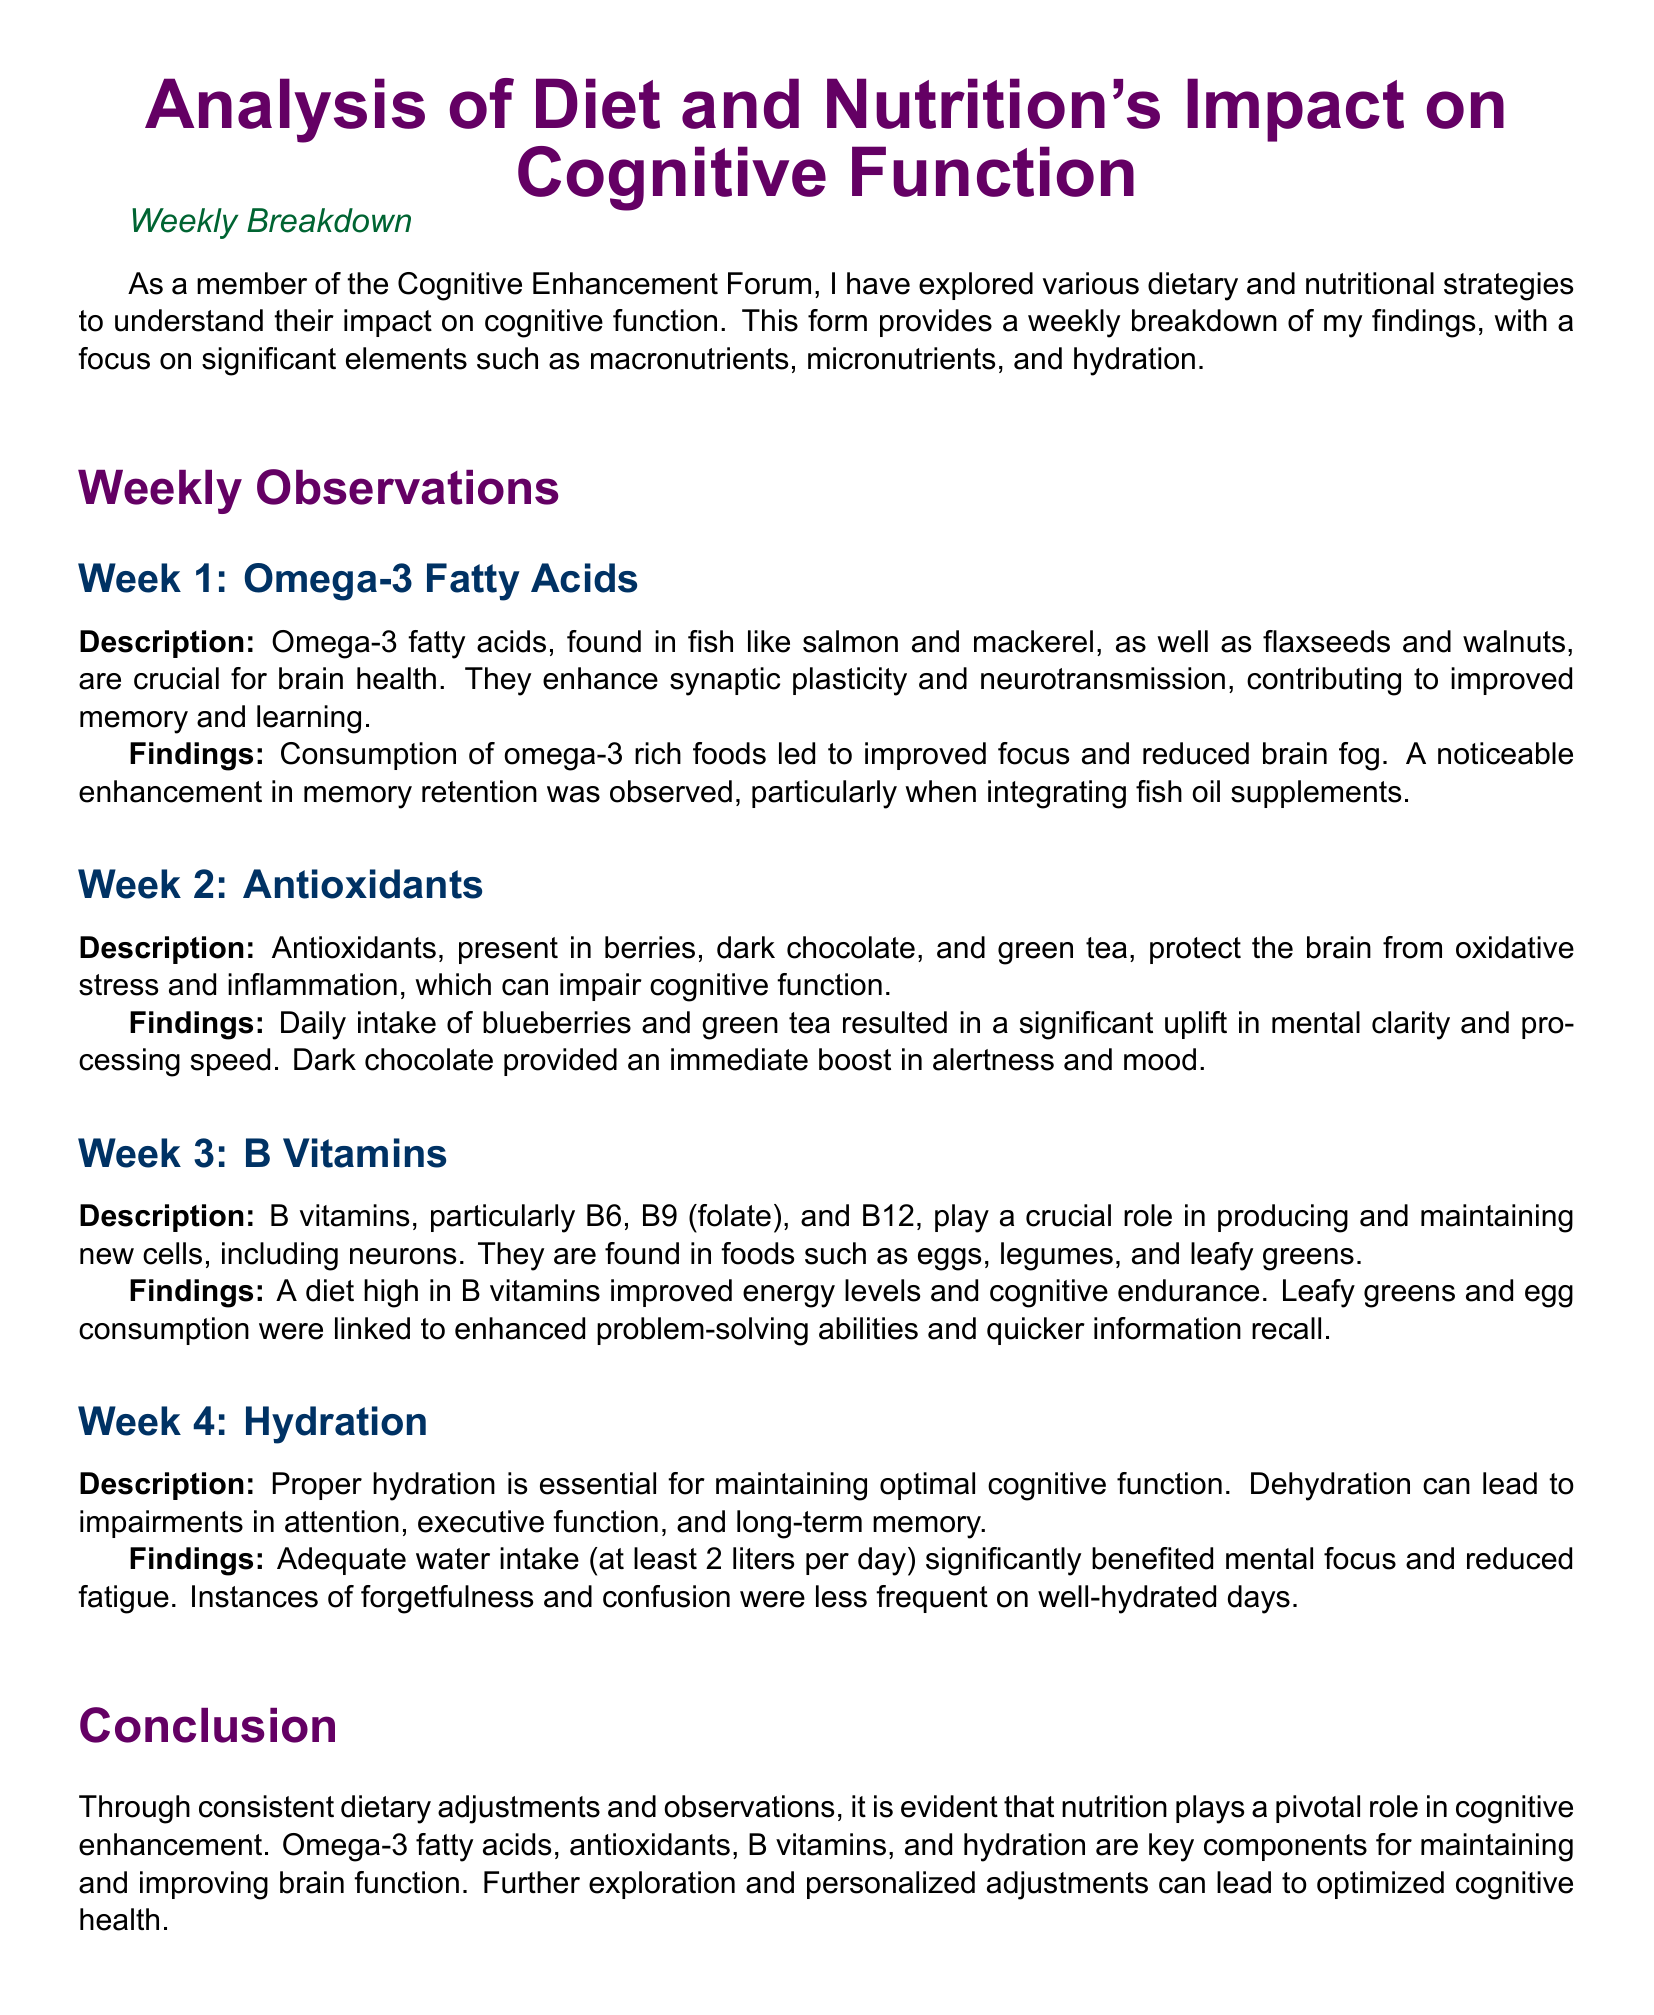What are the key components for maintaining and improving brain function? The key components mentioned in the document for maintaining and improving brain function are omega-3 fatty acids, antioxidants, B vitamins, and hydration.
Answer: omega-3 fatty acids, antioxidants, B vitamins, and hydration Which week focused on hydration? The document has a section for each week, and hydration is discussed in Week 4.
Answer: Week 4 What food group is primarily associated with omega-3 fatty acids? The description highlights fish, such as salmon and mackerel, as the main food group associated with omega-3 fatty acids.
Answer: Fish What effect did antioxidants have on mental clarity? The findings indicate a significant uplift in mental clarity with daily intake of blueberries and green tea.
Answer: Significant uplift How many liters of water were recommended per day for optimal cognitive function? The document states that adequate water intake should be at least 2 liters per day.
Answer: 2 liters Which B vitamins are mentioned in the document? The document lists B6, B9 (folate), and B12 as important B vitamins for cognitive health.
Answer: B6, B9 (folate), and B12 What method was used to observe changes in cognitive function? The document describes making consistent dietary adjustments and observations over a four-week period.
Answer: Dietary adjustments and observations What was the outcome of consuming omega-3 rich foods? The findings noted improved focus and reduced brain fog when consuming omega-3 rich foods.
Answer: Improved focus and reduced brain fog 